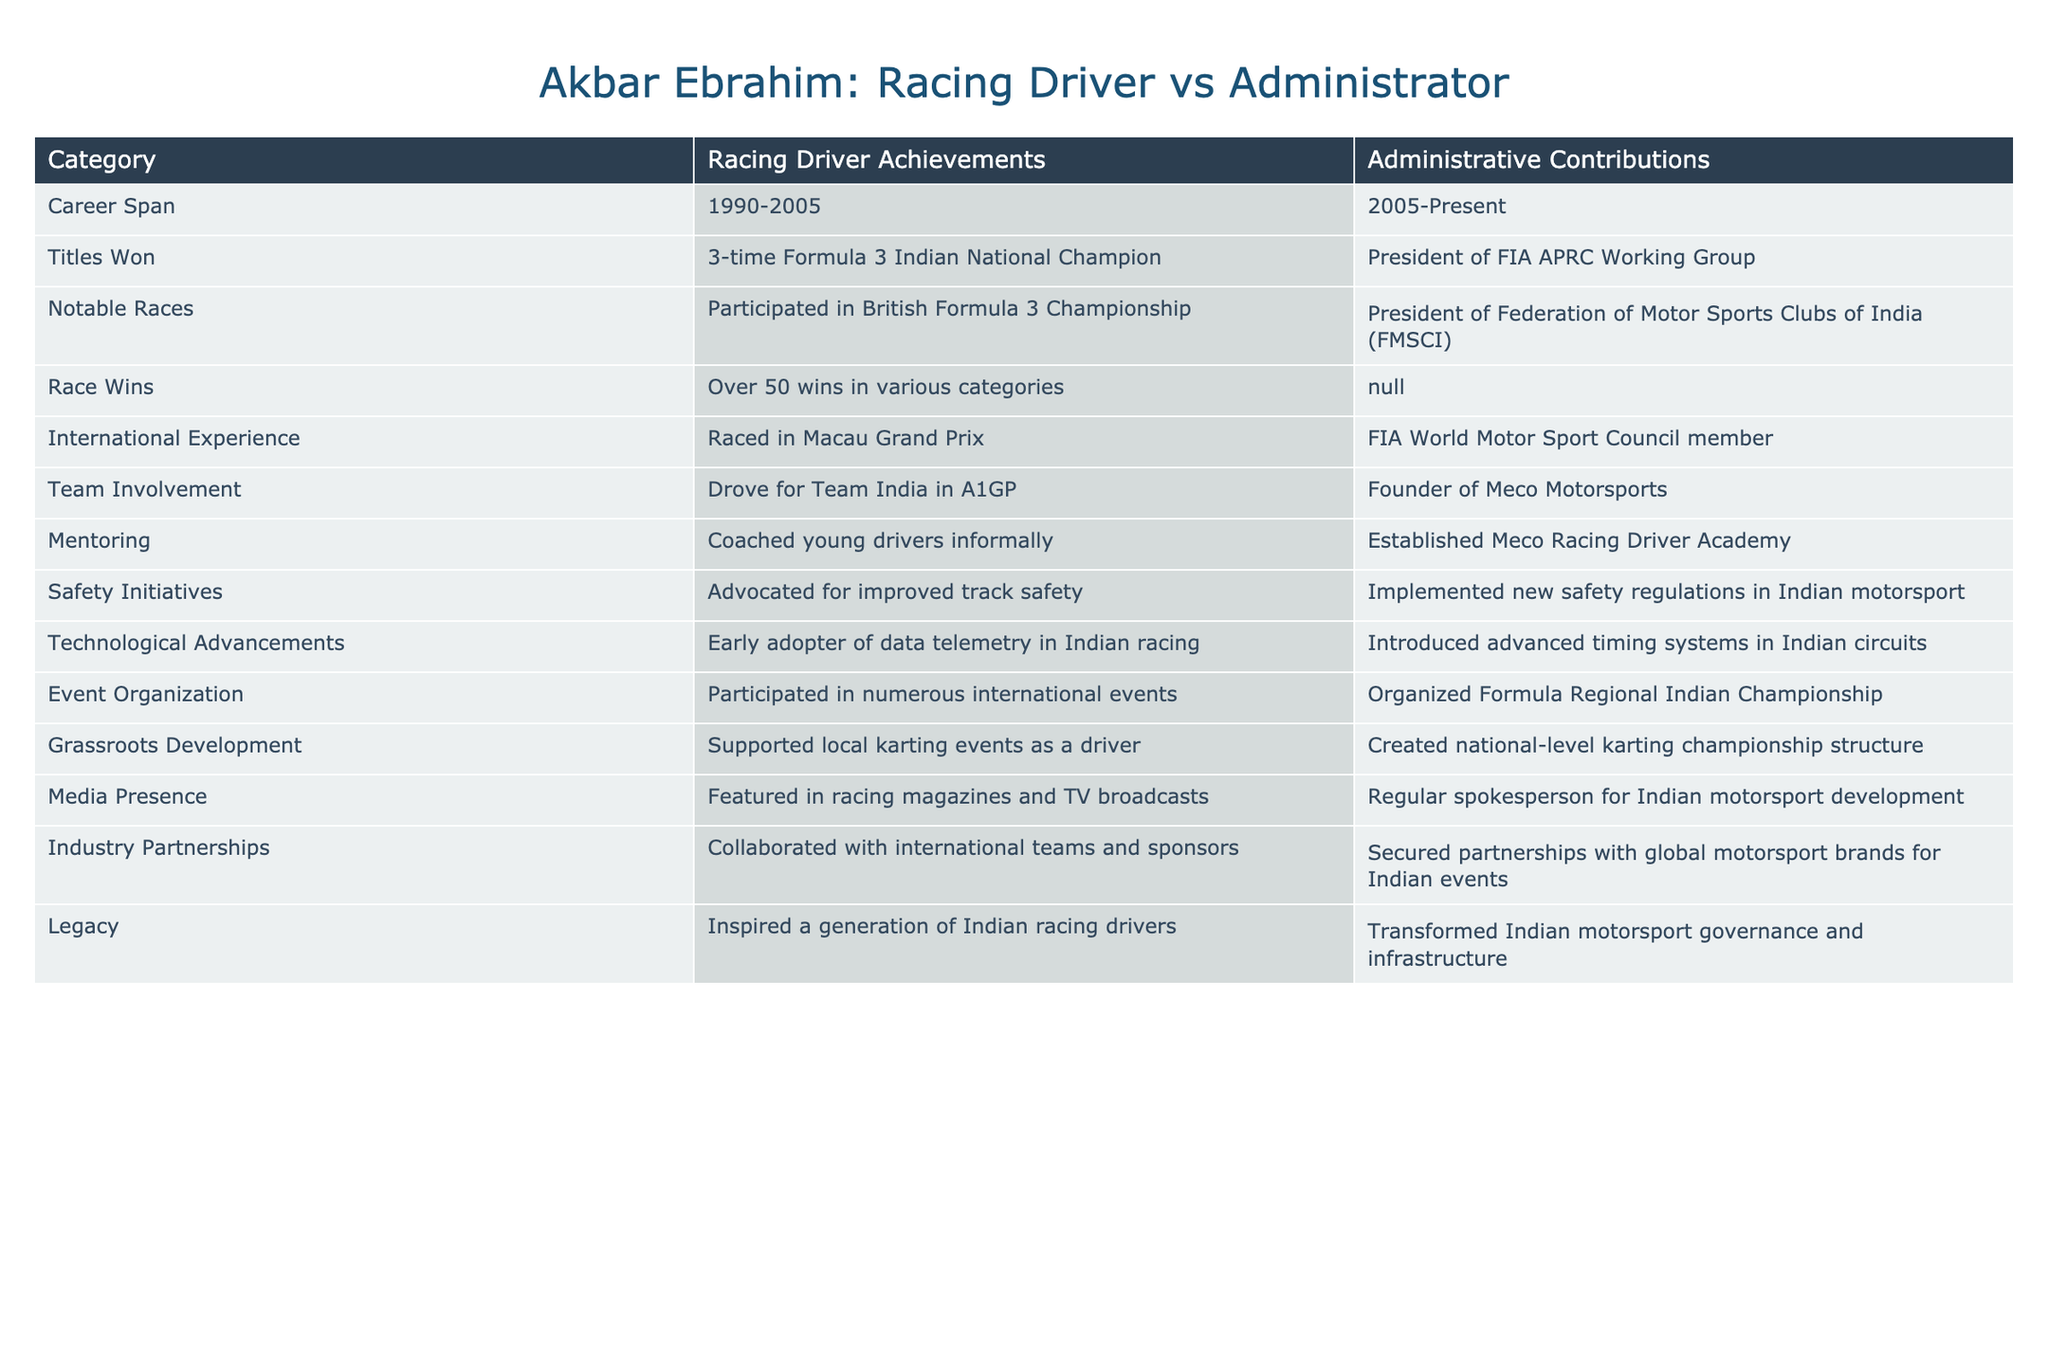What was the career span of Akbar Ebrahim as a racing driver? The table states that Akbar Ebrahim's career span as a racing driver was from 1990 to 2005.
Answer: 1990-2005 How many titles did Akbar Ebrahim win as a racing driver? According to the table, he won 3 titles as a three-time Formula 3 Indian National Champion.
Answer: 3 Did Akbar Ebrahim have any race wins in his administrative role? The table indicates that there are no race wins listed under his administrative contributions, hence the answer is no.
Answer: No What is the notable event that Akbar Ebrahim participated in as a racing driver? The table specifies that he participated in the British Formula 3 Championship as a notable race.
Answer: British Formula 3 Championship Compare the number of total wins in racing driving and whether he held any administrative positions that contributed to race wins. He has over 50 wins as a racing driver, while there are no wins listed under the administrative contributions. Thus, he has 50+ wins only in driving.
Answer: 50+ wins as a driver, 0 as an administrator What roles did Akbar Ebrahim play in mentoring young drivers? The table shows he coached young drivers informally as a driver, and he established the Meco Racing Driver Academy as an administrator.
Answer: Coached informally; Established Meco Racing Driver Academy Did Akbar Ebrahim serve on any global motor sport councils during his administrative career? The table indicates that he is a member of the FIA World Motor Sport Council, affirming his global involvement.
Answer: Yes How did Akbar Ebrahim influence technological advancements in motorsport? The table states that as a driver, he was an early adopter of data telemetry, while as an administrator, he introduced advanced timing systems in Indian circuits.
Answer: Early adopter of data telemetry; Introduced advanced timing systems What contributions did Akbar Ebrahim make to safety in Indian motorsport? As a driver, he advocated for improved track safety, while as an administrator, he implemented new safety regulations.
Answer: Advocated for safety; Implemented regulations What significant organizational role did Akbar Ebrahim take on after his driving career? The table mentions that he organized the Formula Regional Indian Championship after transitioning into administration.
Answer: Organized Formula Regional Indian Championship 